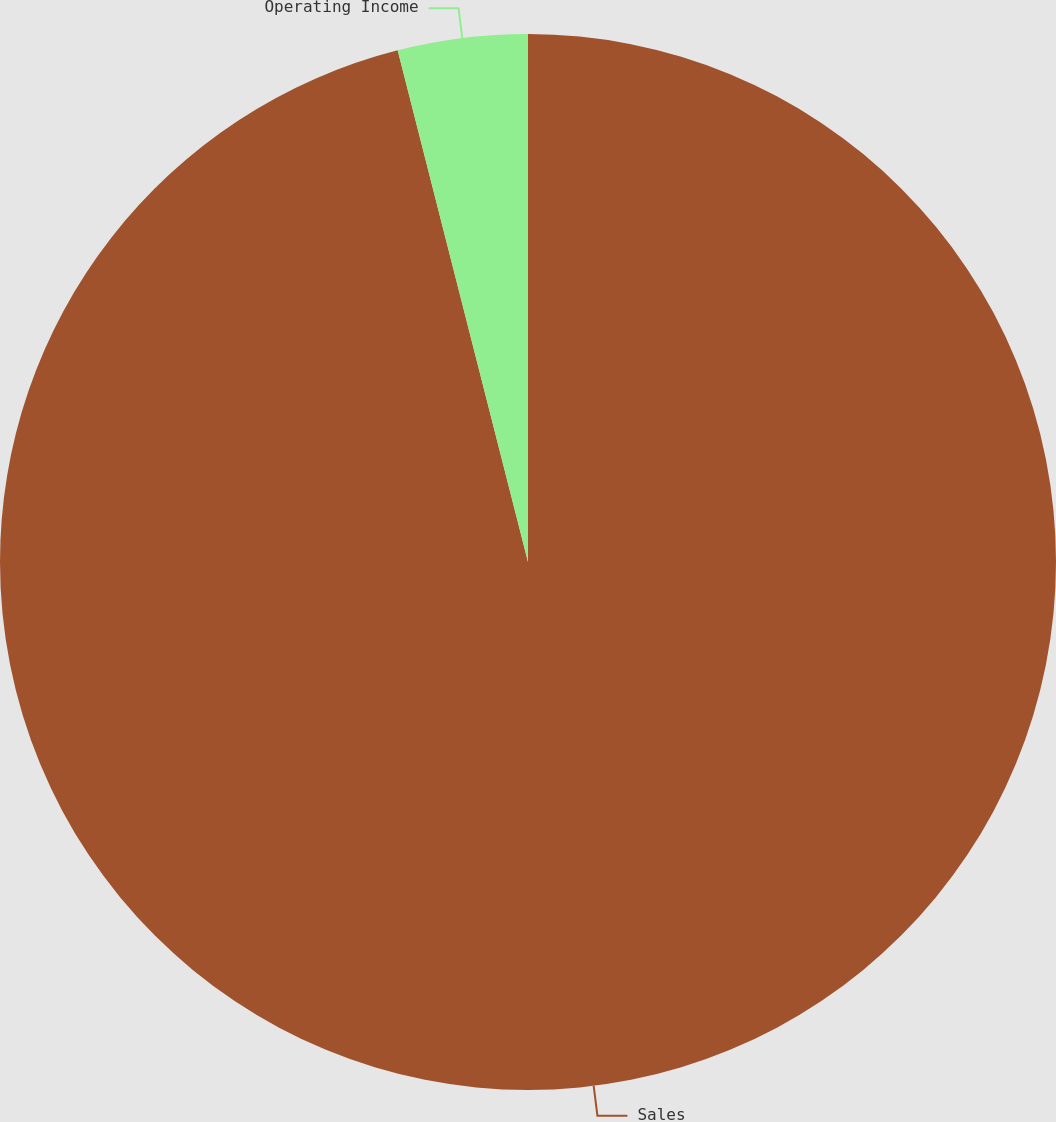Convert chart to OTSL. <chart><loc_0><loc_0><loc_500><loc_500><pie_chart><fcel>Sales<fcel>Operating Income<nl><fcel>96.03%<fcel>3.97%<nl></chart> 